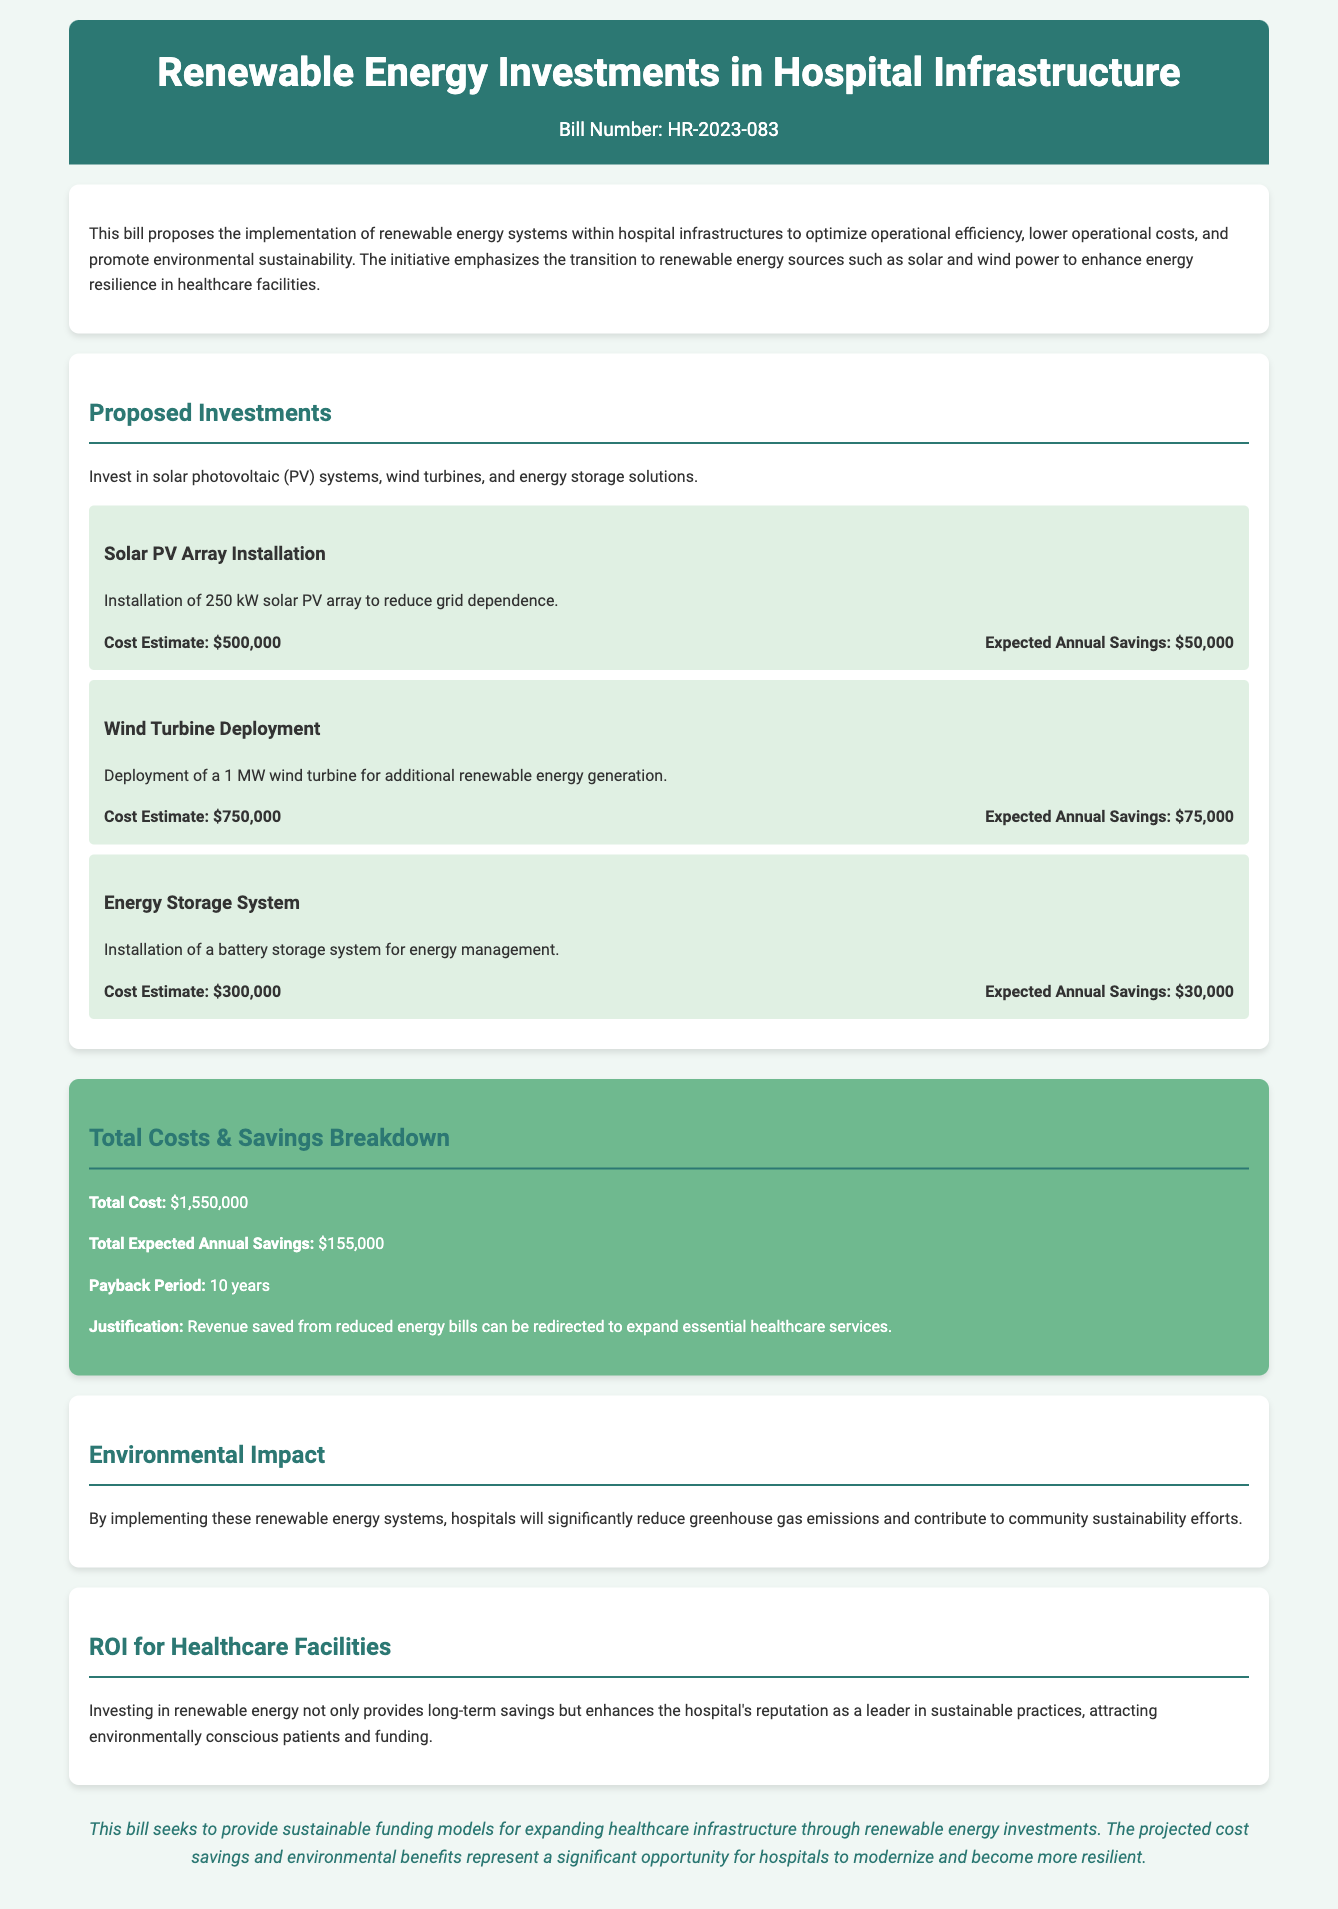what is the bill number? The bill number is stated at the top of the document as HR-2023-083.
Answer: HR-2023-083 what is the cost estimate for the solar PV array installation? The cost estimate for the solar PV array installation is provided in the section detailing the proposed investments, which is $500,000.
Answer: $500,000 what is the expected annual savings from the wind turbine deployment? The expected annual savings from the wind turbine deployment is specified in the component details, which is $75,000.
Answer: $75,000 what is the total expected annual savings from all proposed investments? The total expected annual savings is calculated in the total costs and savings breakdown section, which sums the individual savings to $155,000.
Answer: $155,000 how long is the payback period for the investments? The payback period for the investments is found in the total costs and savings breakdown, which indicates 10 years.
Answer: 10 years what type of energy systems are proposed for hospital infrastructure? The document mentions that investments are in solar photovoltaic (PV) systems, wind turbines, and energy storage solutions.
Answer: solar photovoltaic systems, wind turbines, energy storage solutions what is the justification for redirecting saved revenue? The justification for redirecting saved revenue is presented as reduced energy bills can fund essential healthcare services.
Answer: essential healthcare services what significant benefit is mentioned regarding environmental impact? The document notes that implementing renewable energy systems will significantly reduce greenhouse gas emissions.
Answer: reduce greenhouse gas emissions what is the primary goal of this bill? The primary goal, as stated in the conclusion, is to provide sustainable funding models for expanding healthcare infrastructure.
Answer: sustainable funding models for expanding healthcare infrastructure 